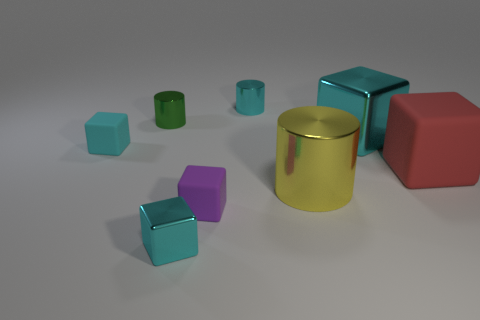Subtract all yellow spheres. How many cyan blocks are left? 3 Subtract all big cyan blocks. How many blocks are left? 4 Subtract all red cubes. How many cubes are left? 4 Subtract all yellow cubes. Subtract all yellow spheres. How many cubes are left? 5 Add 1 red matte objects. How many objects exist? 9 Subtract all blocks. How many objects are left? 3 Add 8 tiny cyan blocks. How many tiny cyan blocks exist? 10 Subtract 0 red cylinders. How many objects are left? 8 Subtract all purple objects. Subtract all purple cubes. How many objects are left? 6 Add 3 big rubber cubes. How many big rubber cubes are left? 4 